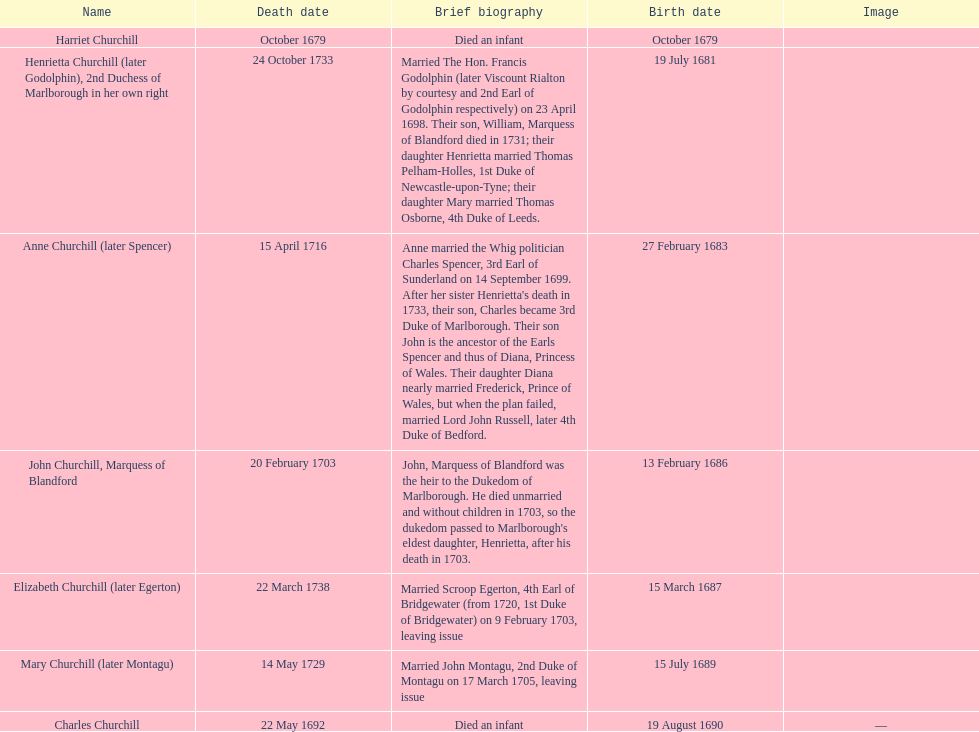Give me the full table as a dictionary. {'header': ['Name', 'Death date', 'Brief biography', 'Birth date', 'Image'], 'rows': [['Harriet Churchill', 'October 1679', 'Died an infant', 'October 1679', ''], ['Henrietta Churchill (later Godolphin), 2nd Duchess of Marlborough in her own right', '24 October 1733', 'Married The Hon. Francis Godolphin (later Viscount Rialton by courtesy and 2nd Earl of Godolphin respectively) on 23 April 1698. Their son, William, Marquess of Blandford died in 1731; their daughter Henrietta married Thomas Pelham-Holles, 1st Duke of Newcastle-upon-Tyne; their daughter Mary married Thomas Osborne, 4th Duke of Leeds.', '19 July 1681', ''], ['Anne Churchill (later Spencer)', '15 April 1716', "Anne married the Whig politician Charles Spencer, 3rd Earl of Sunderland on 14 September 1699. After her sister Henrietta's death in 1733, their son, Charles became 3rd Duke of Marlborough. Their son John is the ancestor of the Earls Spencer and thus of Diana, Princess of Wales. Their daughter Diana nearly married Frederick, Prince of Wales, but when the plan failed, married Lord John Russell, later 4th Duke of Bedford.", '27 February 1683', ''], ['John Churchill, Marquess of Blandford', '20 February 1703', "John, Marquess of Blandford was the heir to the Dukedom of Marlborough. He died unmarried and without children in 1703, so the dukedom passed to Marlborough's eldest daughter, Henrietta, after his death in 1703.", '13 February 1686', ''], ['Elizabeth Churchill (later Egerton)', '22 March 1738', 'Married Scroop Egerton, 4th Earl of Bridgewater (from 1720, 1st Duke of Bridgewater) on 9 February 1703, leaving issue', '15 March 1687', ''], ['Mary Churchill (later Montagu)', '14 May 1729', 'Married John Montagu, 2nd Duke of Montagu on 17 March 1705, leaving issue', '15 July 1689', ''], ['Charles Churchill', '22 May 1692', 'Died an infant', '19 August 1690', '—']]} What is the total number of children listed? 7. 